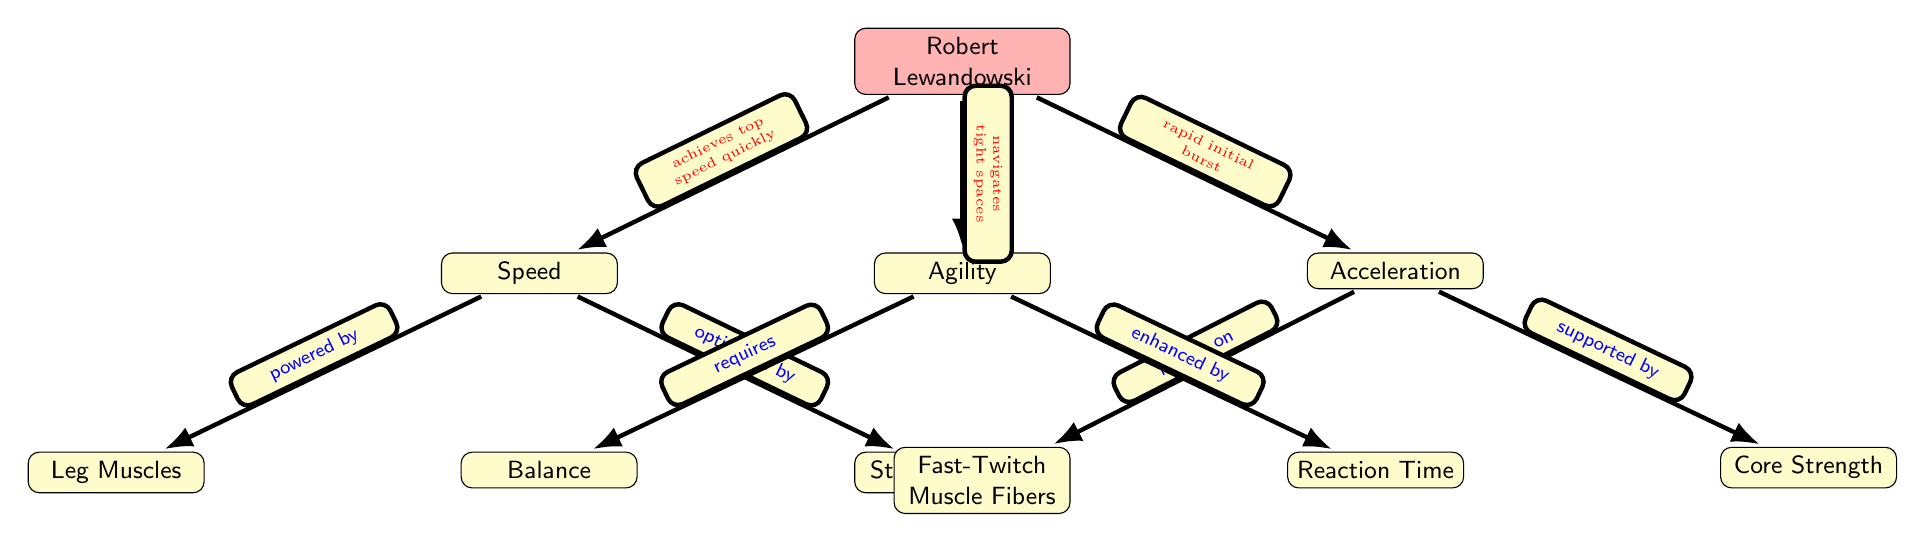What are the three main attributes of Robert Lewandowski's biomechanics? The diagram identifies three main attributes: Speed, Agility, and Acceleration. These are clearly labeled directly below Robert Lewandowski, representing key components of his scoring approach.
Answer: Speed, Agility, Acceleration Which muscle fibers contribute to acceleration? The diagram indicates that Fast-Twitch Muscle Fibers are specifically mentioned as a component that supports Acceleration. This highlights the importance of these fibers in enabling rapid movements.
Answer: Fast-Twitch Muscle Fibers What factor primarily enhances agility? According to the diagram, Reaction Time is described as an enhancement for Agility. This suggests that quicker responses help Lewandowski navigate effectively during play.
Answer: Reaction Time How does Lewandowski achieve high speed? The diagram shows that he "achieves top speed quickly" through the attribute of Speed, indicating a direct relationship between his speed capability and his overall performance.
Answer: achieves top speed quickly What two elements are related to Speed? The diagram specifies that Speed is powered by Leg Muscles and optimized by Stride Length. This means both elements are crucial in enhancing Lewandowski's speed on the field.
Answer: Leg Muscles, Stride Length Explain how core strength affects acceleration. The diagram illustrates that Core Strength is a supporting factor for Acceleration. A strong core is essential for maintaining stability and power during quick bursts of speed, making it integral to Lewandowski's performance.
Answer: supported by Core Strength What is required for agility according to the diagram? Balance is depicted as a necessary factor for Agility. This indicates that maintaining balance is crucial for maneuverability and quick directional changes during play.
Answer: Balance How many nodes are there in the diagram? By inspecting the diagram visually, we count a total of nine nodes: one for Lewandowski, three main attributes (Speed, Agility, Acceleration), and five supporting elements. This total indicates a comprehensive overview of factors affecting his performance.
Answer: nine What color represents Robert Lewandowski in the diagram? The diagram uses a distinct red shade to depict Robert Lewandowski. This helps differentiate him from other nodes, highlighting his central role in the depiction.
Answer: red 